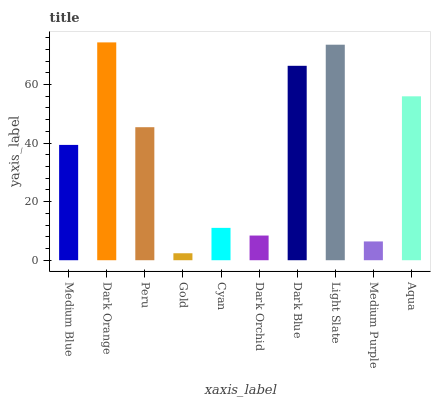Is Gold the minimum?
Answer yes or no. Yes. Is Dark Orange the maximum?
Answer yes or no. Yes. Is Peru the minimum?
Answer yes or no. No. Is Peru the maximum?
Answer yes or no. No. Is Dark Orange greater than Peru?
Answer yes or no. Yes. Is Peru less than Dark Orange?
Answer yes or no. Yes. Is Peru greater than Dark Orange?
Answer yes or no. No. Is Dark Orange less than Peru?
Answer yes or no. No. Is Peru the high median?
Answer yes or no. Yes. Is Medium Blue the low median?
Answer yes or no. Yes. Is Dark Orange the high median?
Answer yes or no. No. Is Gold the low median?
Answer yes or no. No. 